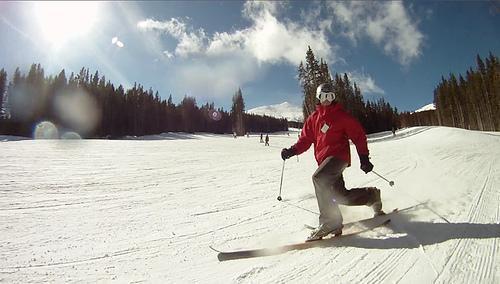How many people are shown?
Give a very brief answer. 7. 